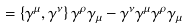<formula> <loc_0><loc_0><loc_500><loc_500>= \left \{ \gamma ^ { \mu } , \gamma ^ { \nu } \right \} \gamma ^ { \rho } \gamma _ { \mu } - \gamma ^ { \nu } \gamma ^ { \mu } \gamma ^ { \rho } \gamma _ { \mu }</formula> 